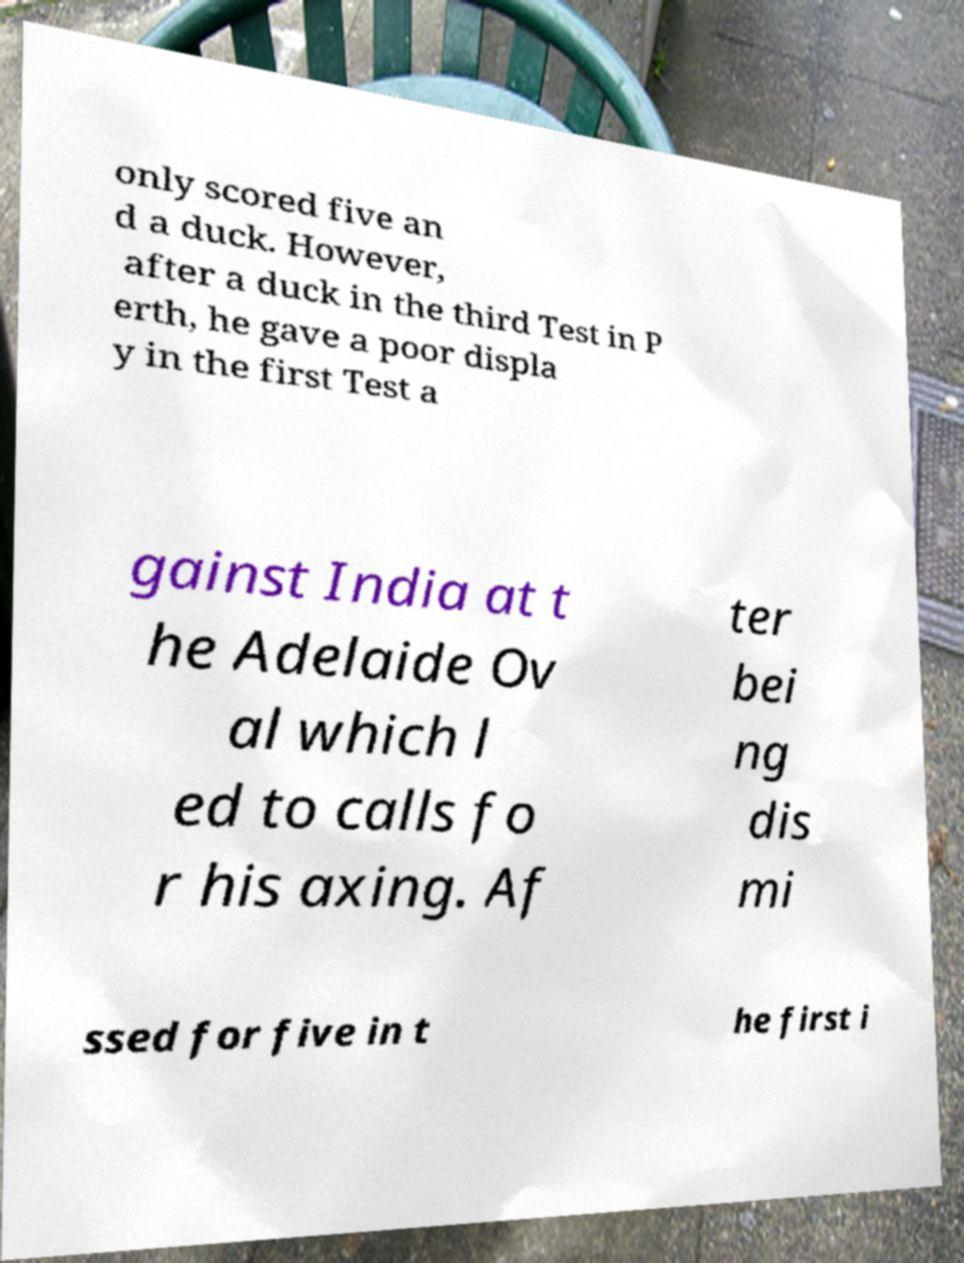Can you read and provide the text displayed in the image?This photo seems to have some interesting text. Can you extract and type it out for me? only scored five an d a duck. However, after a duck in the third Test in P erth, he gave a poor displa y in the first Test a gainst India at t he Adelaide Ov al which l ed to calls fo r his axing. Af ter bei ng dis mi ssed for five in t he first i 